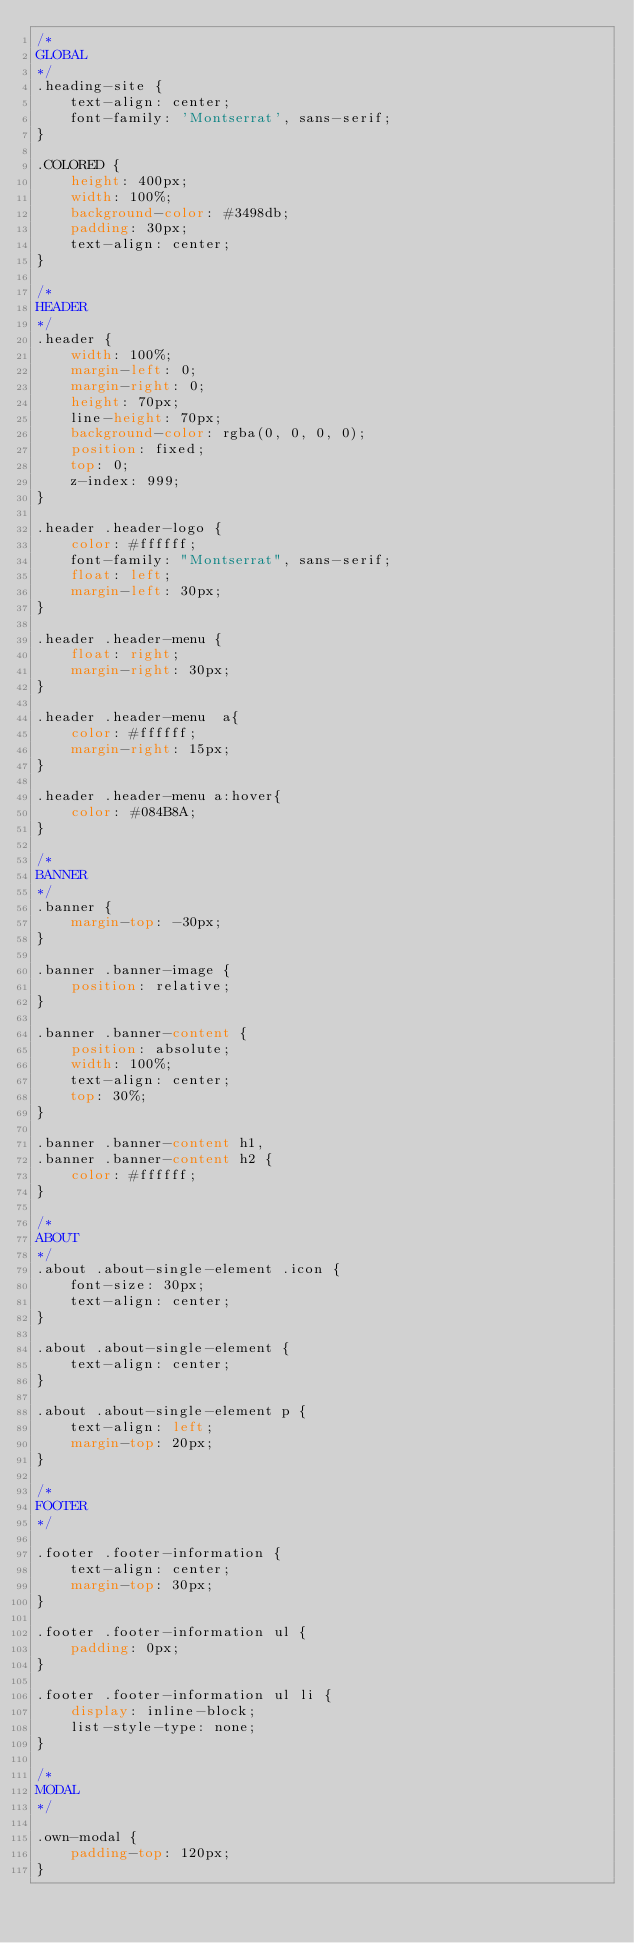<code> <loc_0><loc_0><loc_500><loc_500><_CSS_>/*
GLOBAL
*/
.heading-site {
    text-align: center;
    font-family: 'Montserrat', sans-serif;
}

.COLORED {
    height: 400px;
    width: 100%;
    background-color: #3498db;
    padding: 30px;
    text-align: center;
}

/*
HEADER
*/
.header {
    width: 100%;
    margin-left: 0;
    margin-right: 0;
    height: 70px;
    line-height: 70px;
    background-color: rgba(0, 0, 0, 0);
    position: fixed;
    top: 0;
    z-index: 999;
}

.header .header-logo {
    color: #ffffff;
    font-family: "Montserrat", sans-serif;
    float: left;
    margin-left: 30px;
}

.header .header-menu {
    float: right;
    margin-right: 30px;
}

.header .header-menu  a{
    color: #ffffff;
    margin-right: 15px; 
}

.header .header-menu a:hover{
    color: #084B8A; 
}

/*
BANNER
*/
.banner {
    margin-top: -30px;
}

.banner .banner-image {
    position: relative;
}

.banner .banner-content {
    position: absolute;
    width: 100%;
    text-align: center;
    top: 30%;
}

.banner .banner-content h1,
.banner .banner-content h2 {
    color: #ffffff;
}

/*
ABOUT
*/
.about .about-single-element .icon {
    font-size: 30px;
    text-align: center;
}

.about .about-single-element {
    text-align: center;
}

.about .about-single-element p {
    text-align: left;
    margin-top: 20px;
}

/*
FOOTER
*/

.footer .footer-information {
    text-align: center;
    margin-top: 30px;
}

.footer .footer-information ul {
    padding: 0px;
}

.footer .footer-information ul li {
    display: inline-block;
    list-style-type: none;
}

/*
MODAL
*/

.own-modal {
    padding-top: 120px;
}</code> 